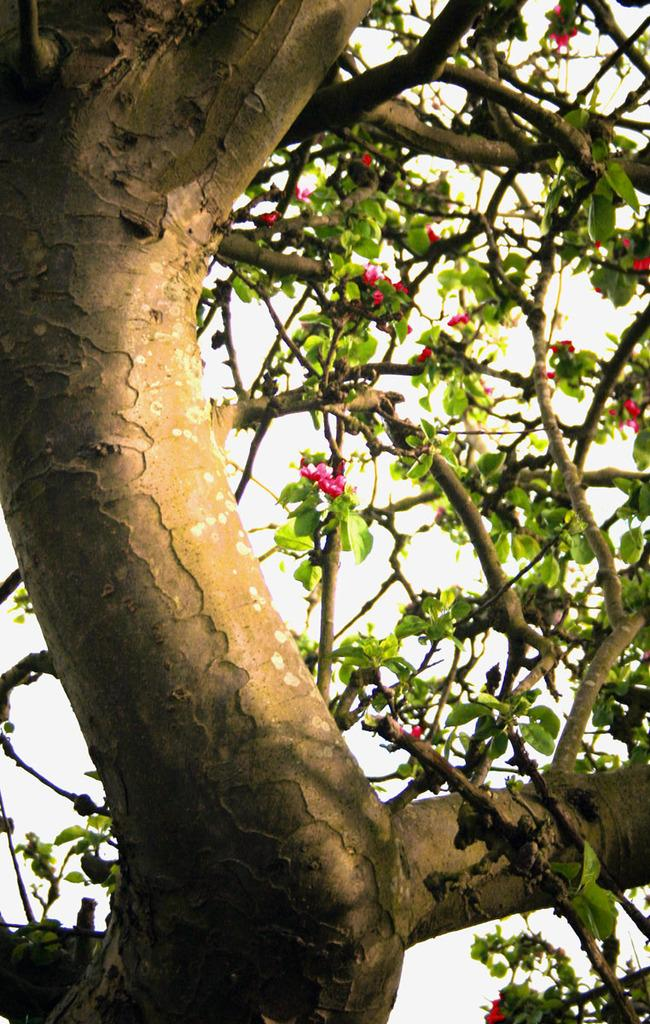What type of plant can be seen in the image? There is a tree in the image. Can you describe the tree's features? The tree has branches, leaves, and flowers. What is the color of the background in the image? The background of the image is white. Is there a spy observing the tree in the image? There is no indication of a spy or any person in the image; it only features a tree with branches, leaves, and flowers against a white background. 